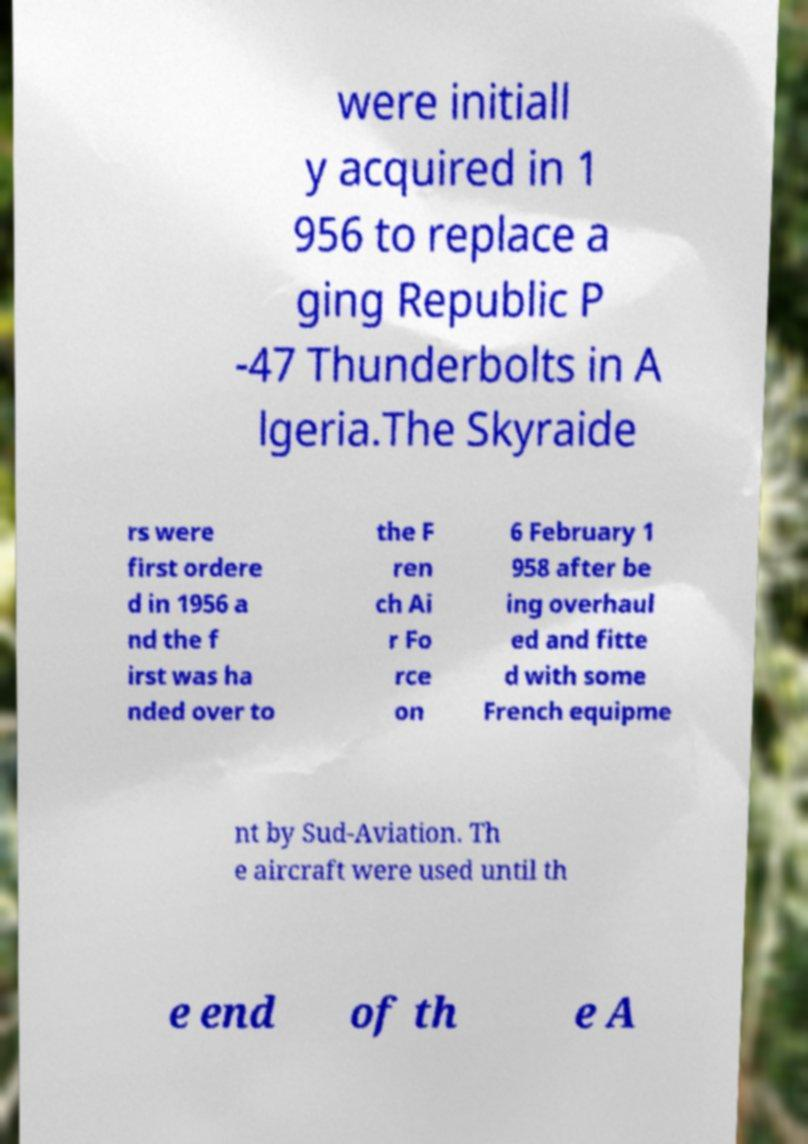For documentation purposes, I need the text within this image transcribed. Could you provide that? were initiall y acquired in 1 956 to replace a ging Republic P -47 Thunderbolts in A lgeria.The Skyraide rs were first ordere d in 1956 a nd the f irst was ha nded over to the F ren ch Ai r Fo rce on 6 February 1 958 after be ing overhaul ed and fitte d with some French equipme nt by Sud-Aviation. Th e aircraft were used until th e end of th e A 